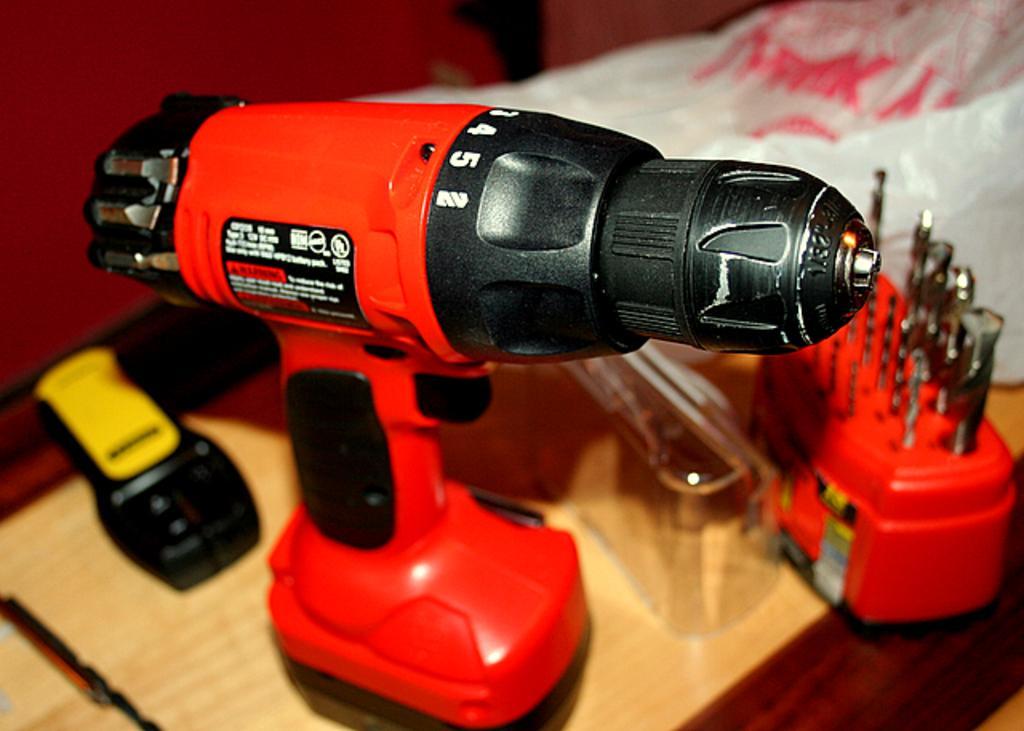How would you summarize this image in a sentence or two? In the image in the center, we can see one table. On the table, we can see one handheld power drill, plastic cover, remote, red box and a few other objects. 